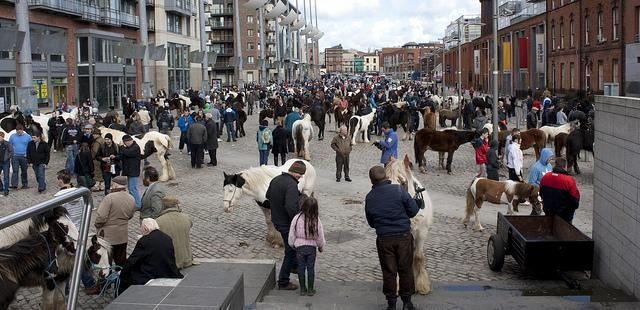What animal are the people checking out?

Choices:
A) goats
B) lambs
C) donkeys
D) horses horses 